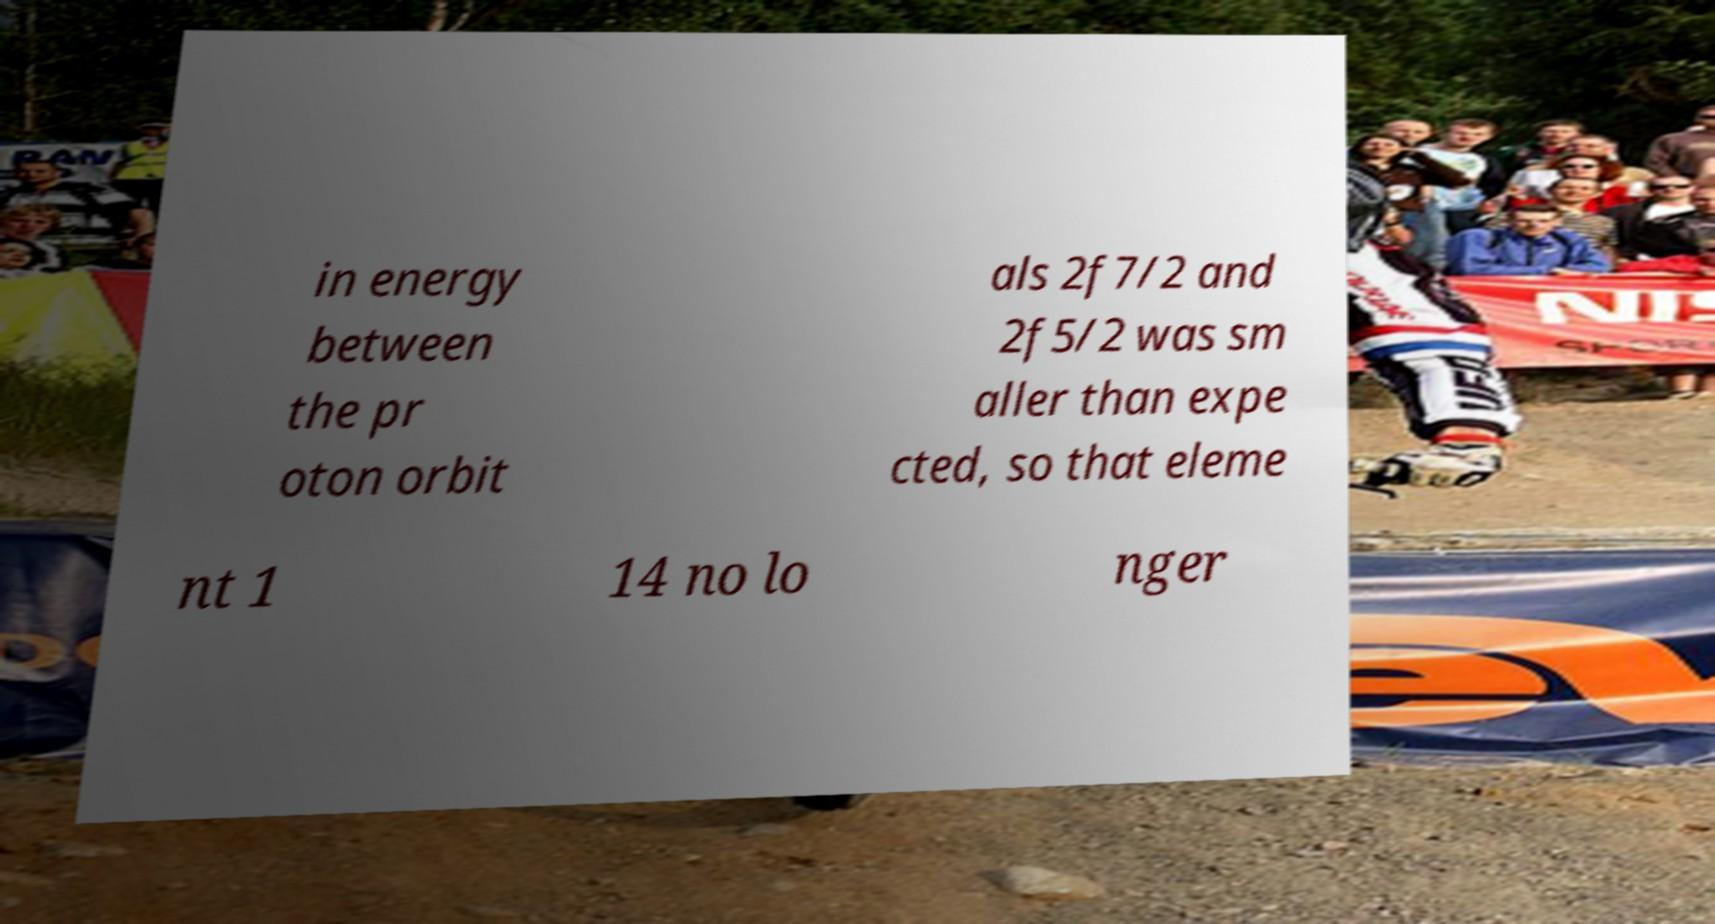Please identify and transcribe the text found in this image. in energy between the pr oton orbit als 2f7/2 and 2f5/2 was sm aller than expe cted, so that eleme nt 1 14 no lo nger 